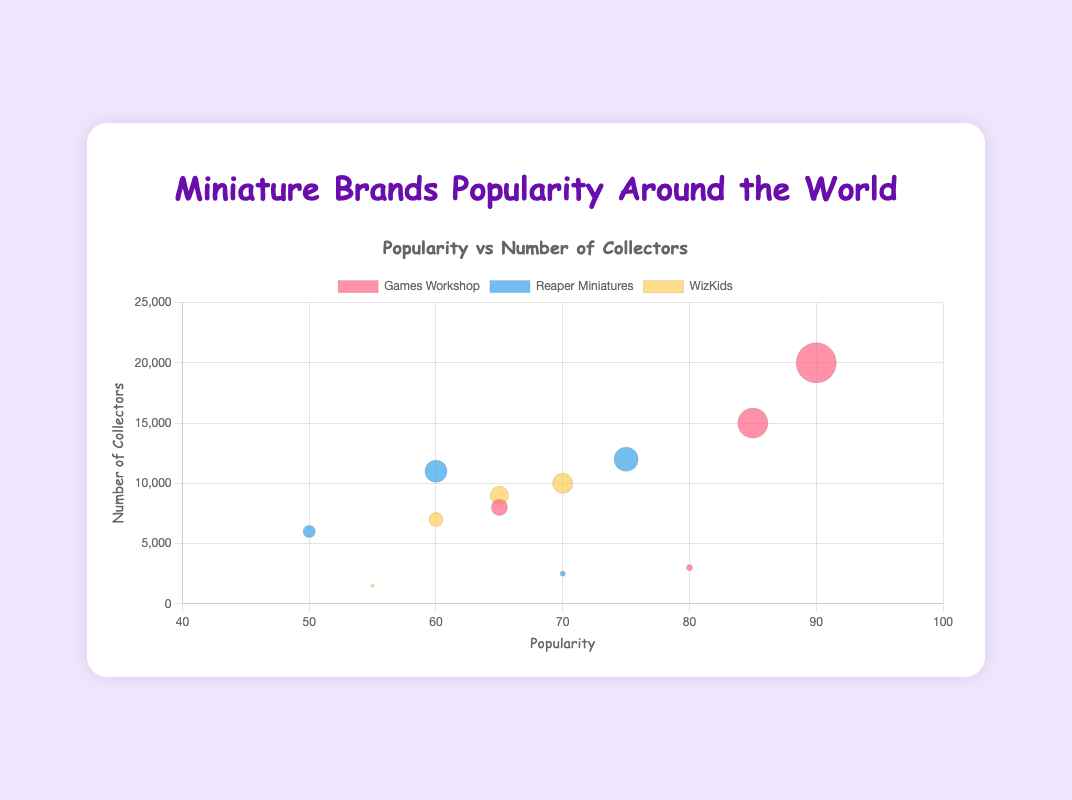What is the title of the bubble chart? The title of the bubble chart is typically found at the top of the chart. In this case, the title is displayed prominently in the center inside a heading element.
Answer: Miniature Brands Popularity Around the World How many data points represent the brand "Reaper Miniatures"? By looking at the chart, we can count the number of bubbles associated with the "Reaper Miniatures" label. Each region has one bubble for "Reaper Miniatures", so you would count four bubbles representing it.
Answer: Four Which brand is most popular in Europe? To determine the most popular brand in Europe, we look at the "x" coordinate values of the bubbles for each brand in the Europe region. The brand with the highest "x" value in Europe is Games Workshop with a popularity of 90.
Answer: Games Workshop Which region has the least number of collectors for WizKids? Look for the smallest "y" coordinate value among the bubbles for the WizKids dataset. The bubble with the smallest "y" value indicates the region with the least number of collectors. In this case, the smallest "y" value is 1,500, which corresponds to Australia.
Answer: Australia What's the combined number of collectors for Games Workshop in North America and Europe? Add the number of collectors for Games Workshop in North America (15,000) and in Europe (20,000). The combined number is 15,000 + 20,000 = 35,000.
Answer: 35,000 What's the average popularity of Reaper Miniatures across all regions? To find the average popularity, sum the popularity values for Reaper Miniatures in each region (75 + 60 + 50 + 70) and divide by the number of regions (4). (75 + 60 + 50 + 70) / 4 = 63.75
Answer: 63.75 Which brand and region combination has the smallest bubble size? The bubble size indicates the radius "r" of each bubble. By visually inspecting the bubbles, the smallest bubble represents Reaper Miniatures in Australia with a radius of 2.5.
Answer: Reaper Miniatures in Australia How does the popularity of Games Workshop in Asia compare to that in Europe? Compare the "x" values for Games Workshop in Asia (65) and in Europe (90). Games Workshop is less popular in Asia compared to Europe as 65 < 90.
Answer: Less popular in Asia What is the total number of collectors for WizKids across all regions? Add the number of collectors for WizKids in each region: North America (9000), Europe (10000), Asia (7000), and Australia (1500). The total is 9,000 + 10,000 + 7,000 + 1,500 = 27,500.
Answer: 27,500 What is the popularity range for WizKids in different regions? To find the range, subtract the minimum popularity value for WizKids from the maximum. The min value is 55 (Australia), and the max value is 70 (Europe). The range is 70 - 55 = 15.
Answer: 15 